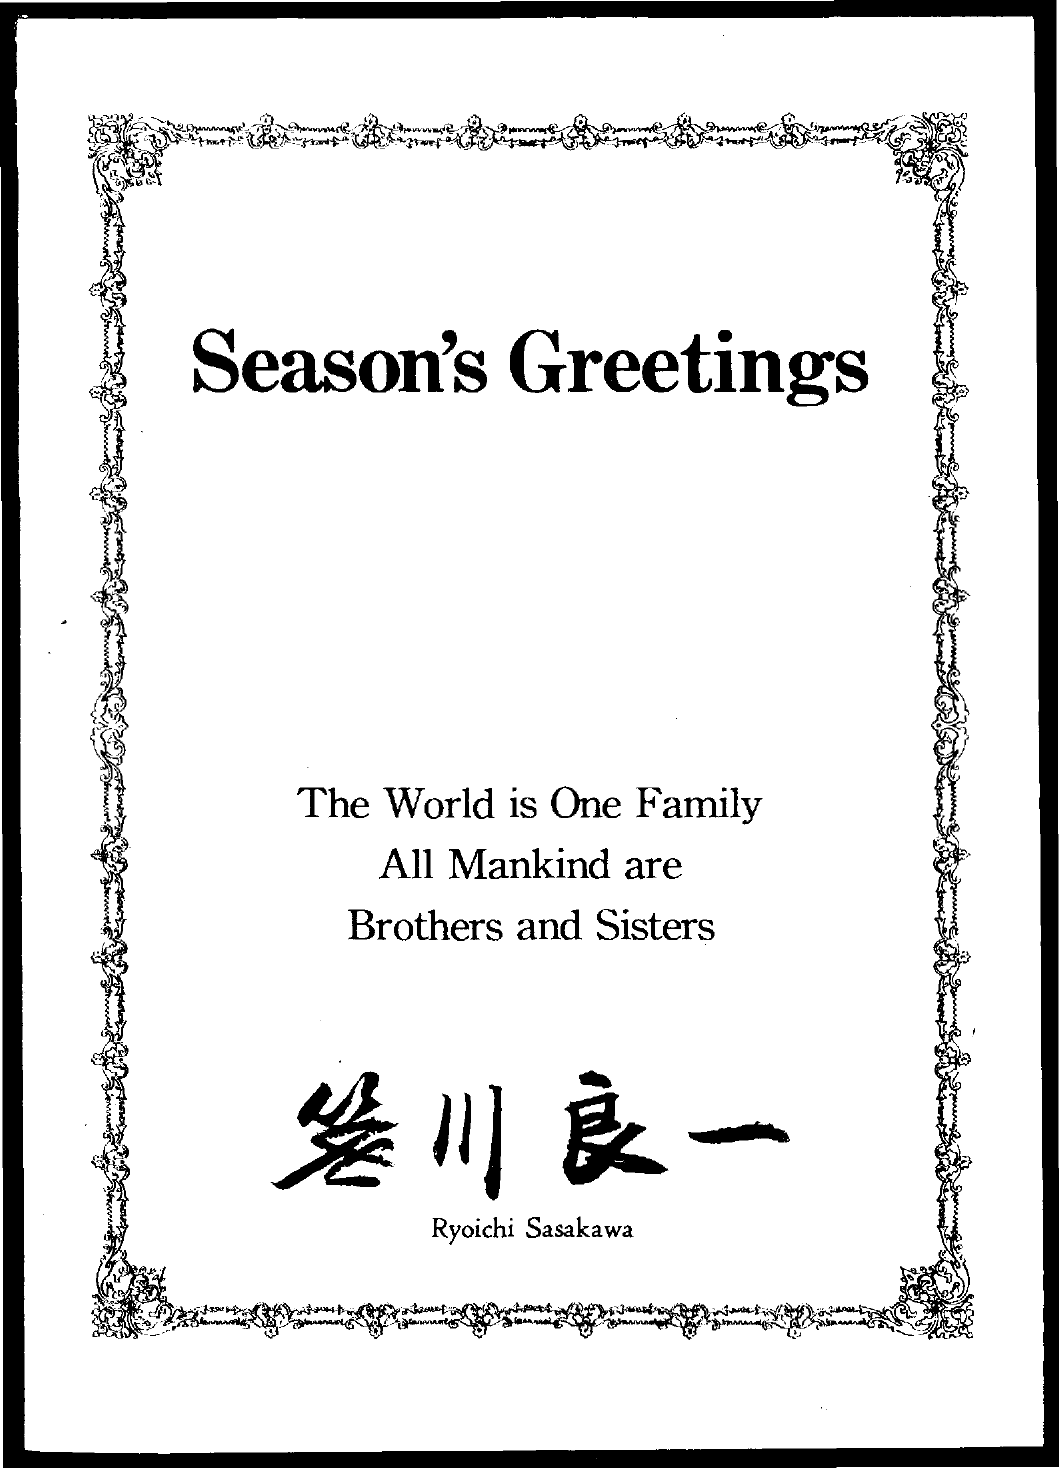Highlight a few significant elements in this photo. The title of the document is 'Season's Greetings.' 